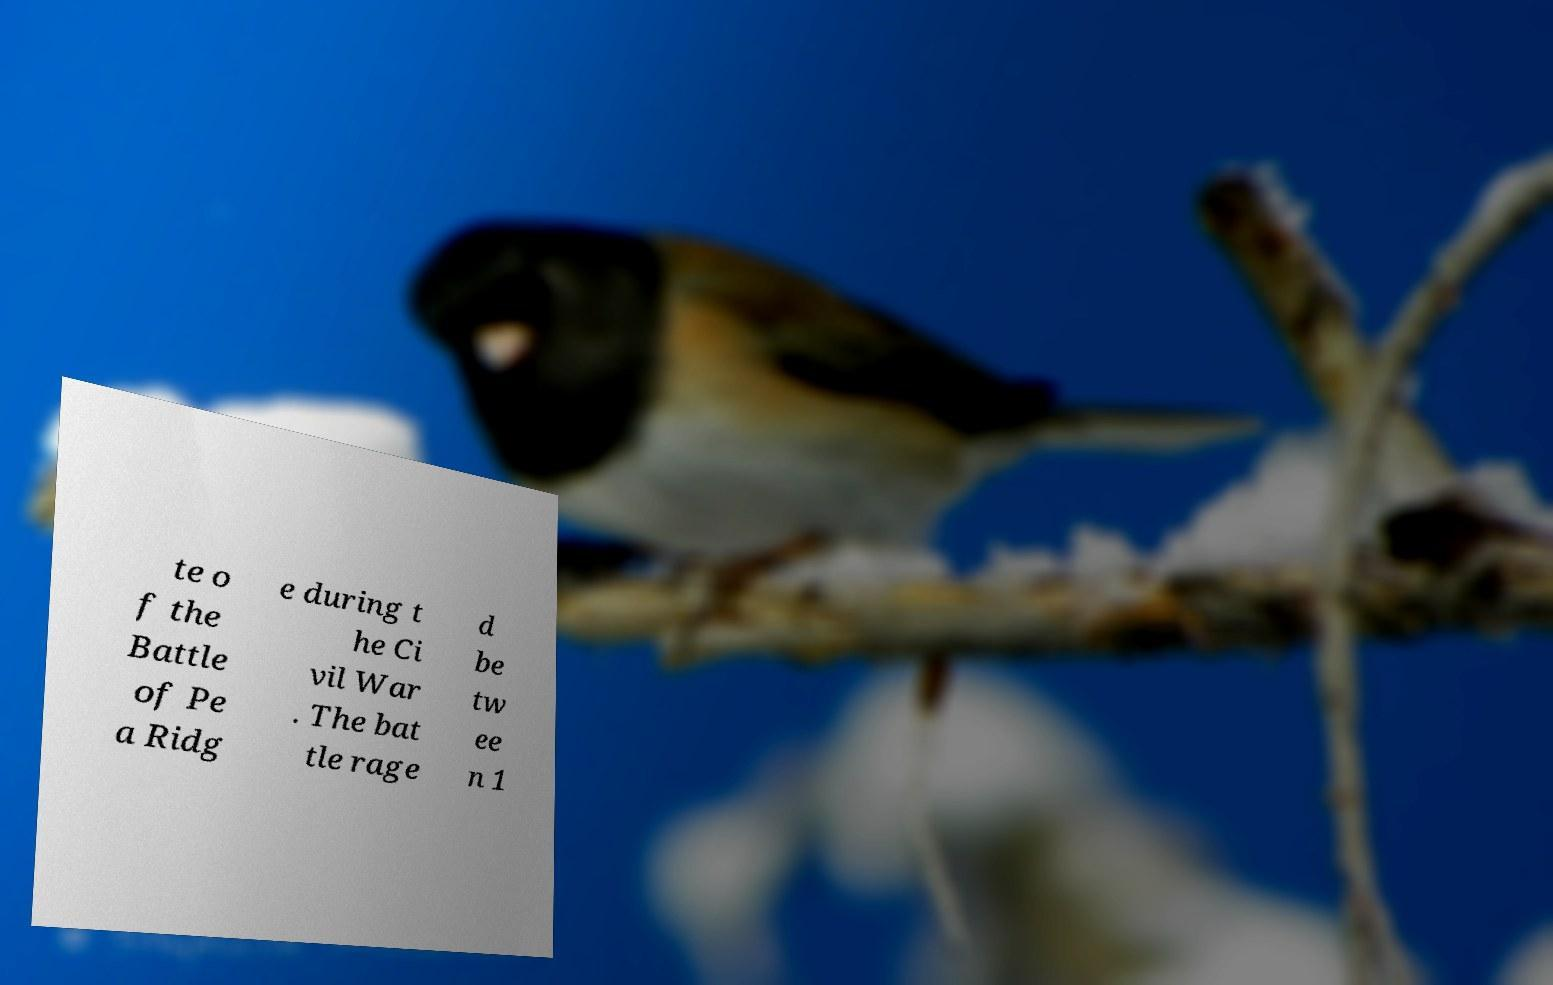I need the written content from this picture converted into text. Can you do that? te o f the Battle of Pe a Ridg e during t he Ci vil War . The bat tle rage d be tw ee n 1 